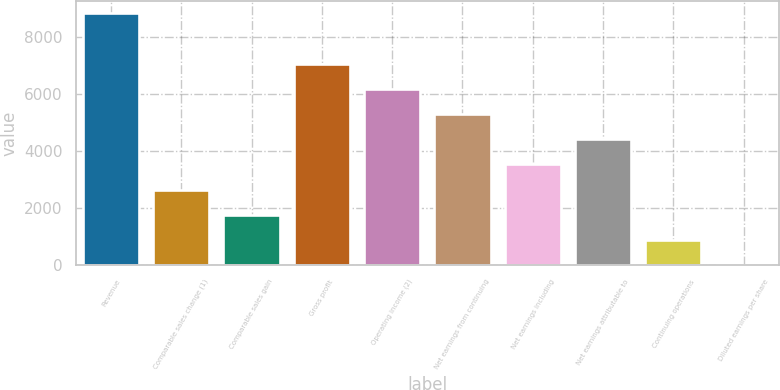<chart> <loc_0><loc_0><loc_500><loc_500><bar_chart><fcel>Revenue<fcel>Comparable sales change (1)<fcel>Comparable sales gain<fcel>Gross profit<fcel>Operating income (2)<fcel>Net earnings from continuing<fcel>Net earnings including<fcel>Net earnings attributable to<fcel>Continuing operations<fcel>Diluted earnings per share<nl><fcel>8819<fcel>2645.94<fcel>1764.08<fcel>7055.24<fcel>6173.38<fcel>5291.52<fcel>3527.8<fcel>4409.66<fcel>882.22<fcel>0.36<nl></chart> 